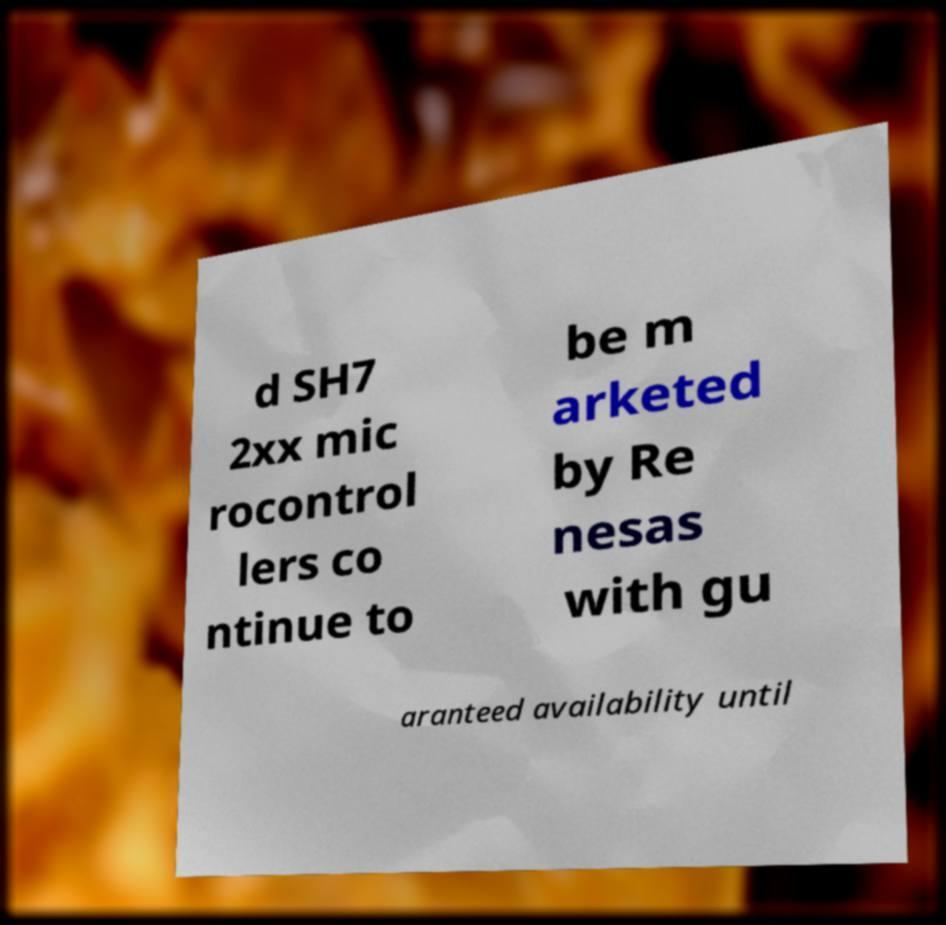Can you accurately transcribe the text from the provided image for me? d SH7 2xx mic rocontrol lers co ntinue to be m arketed by Re nesas with gu aranteed availability until 